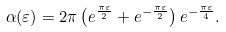<formula> <loc_0><loc_0><loc_500><loc_500>\alpha ( \varepsilon ) = 2 \pi \left ( e ^ { \frac { \pi \varepsilon } { 2 } } + e ^ { - \frac { \pi \varepsilon } { 2 } } \right ) e ^ { - \frac { \pi \varepsilon } { 4 } } .</formula> 